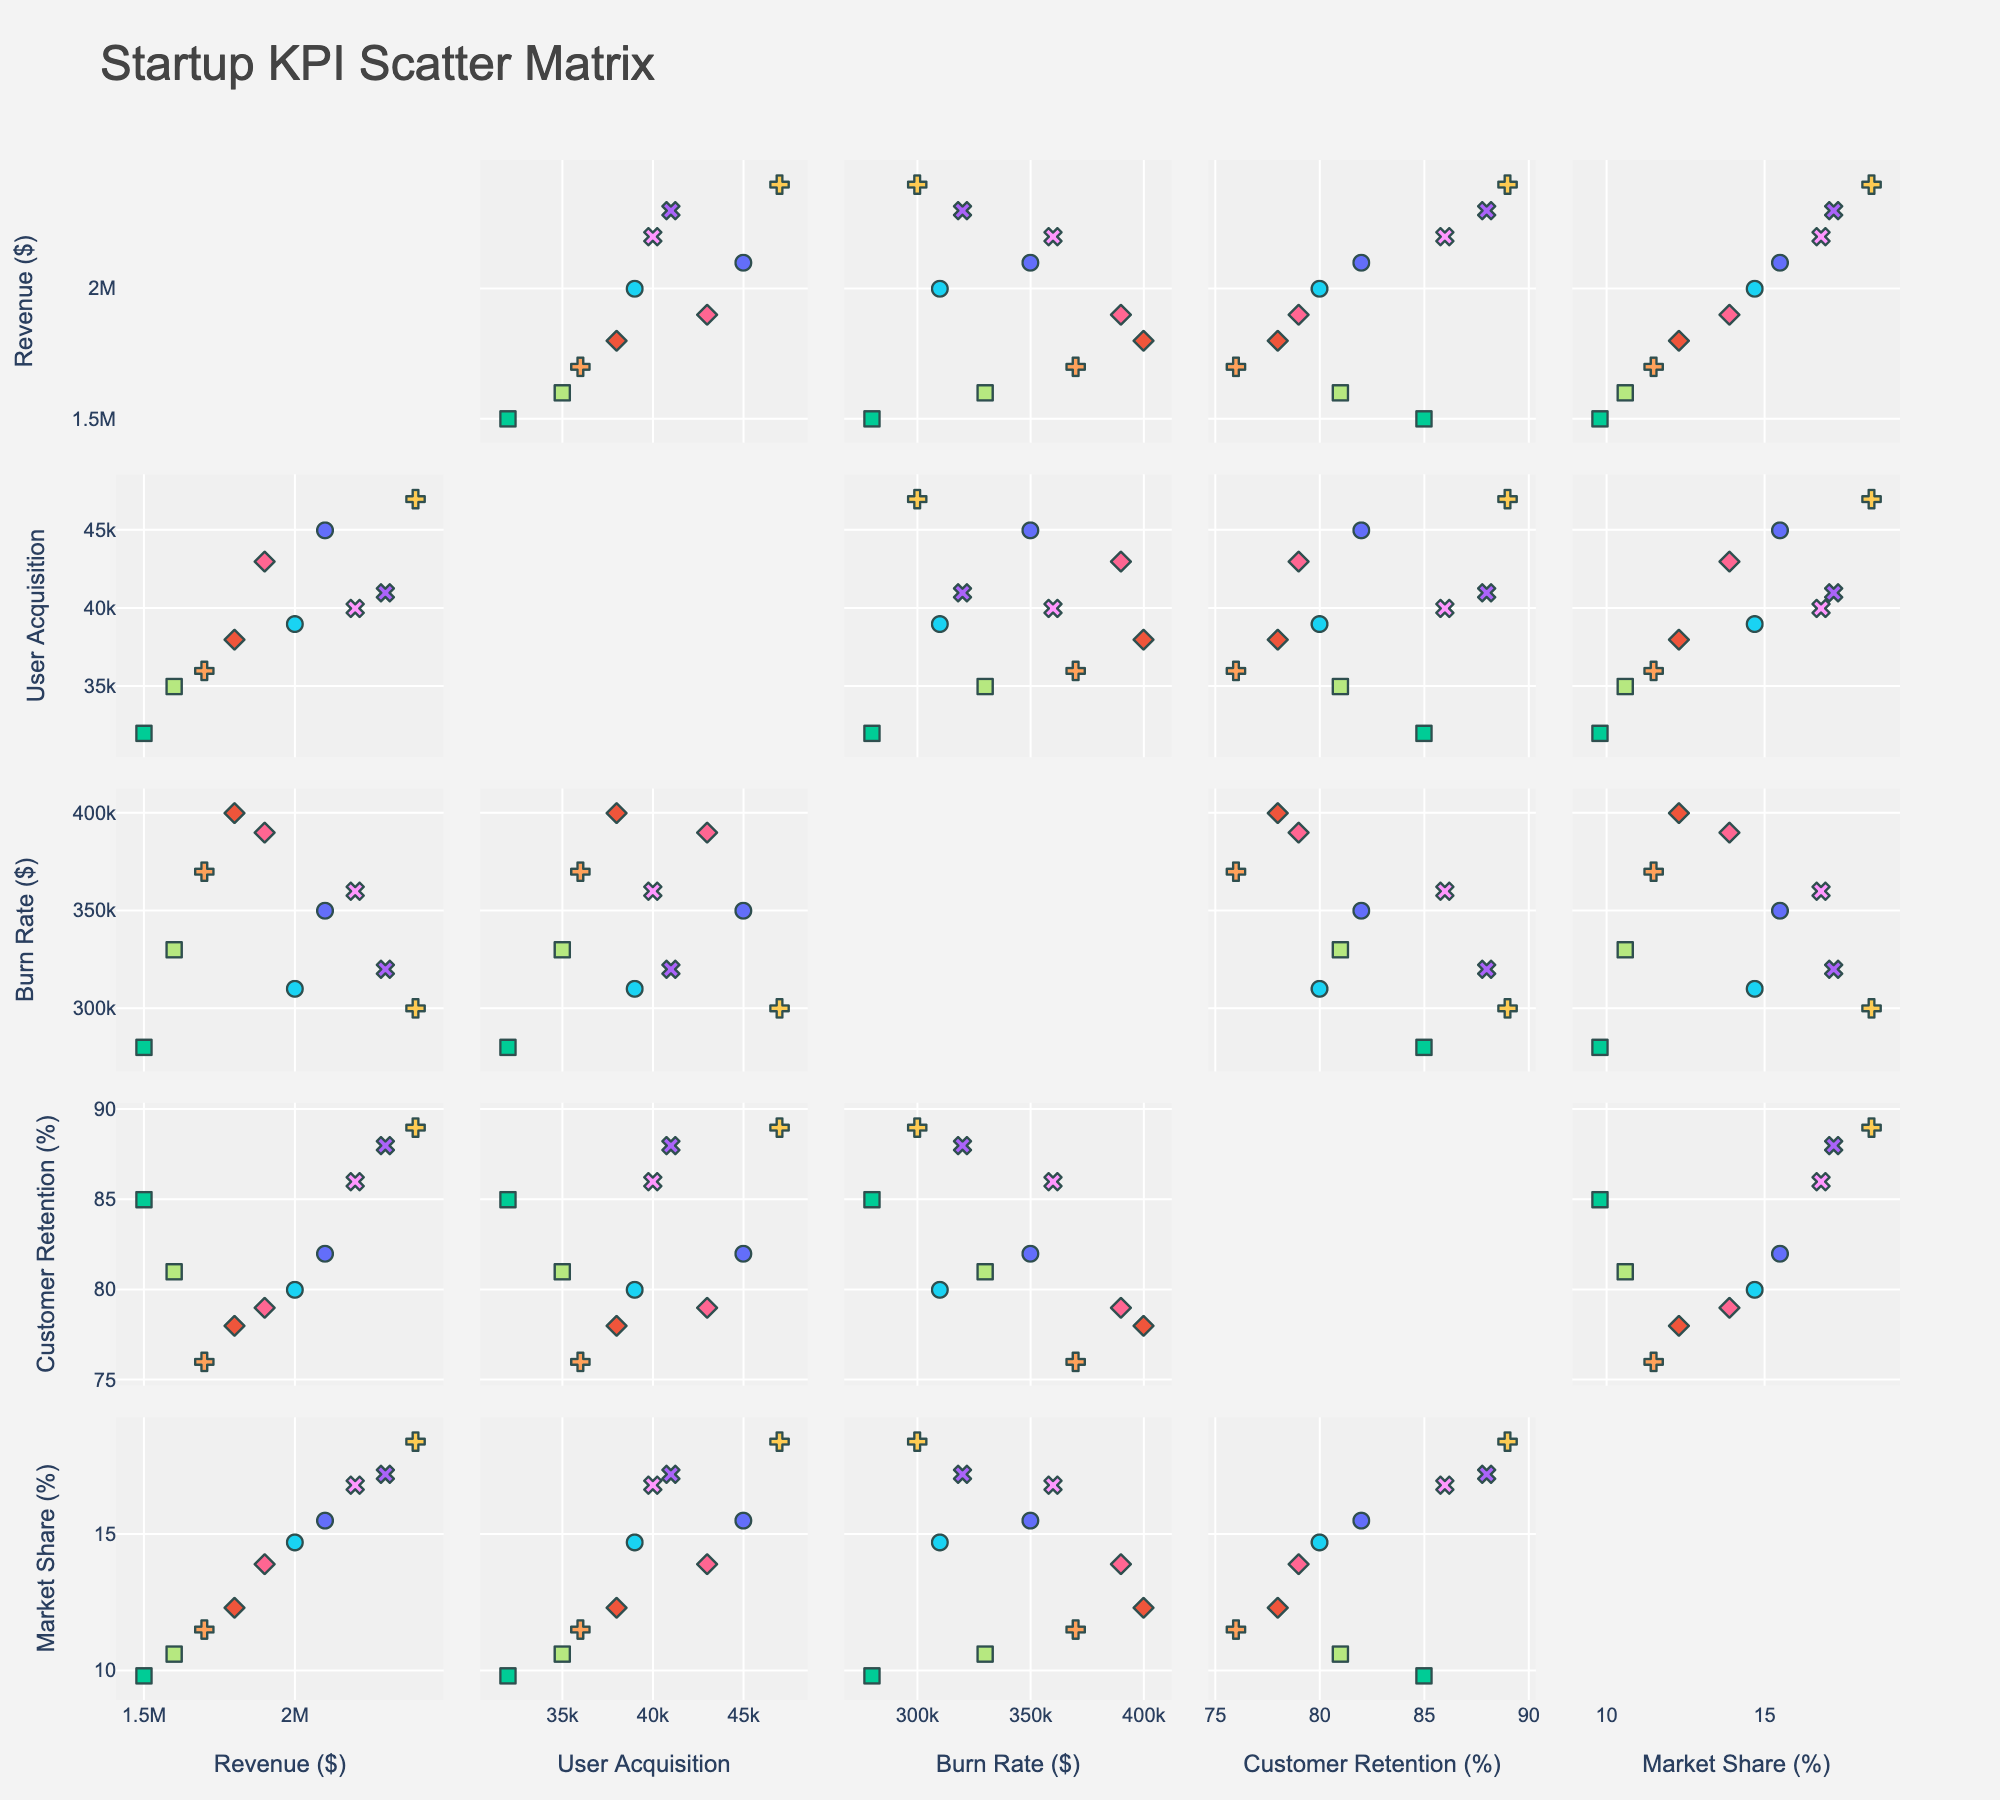What is the title of the figure? To determine the title, look at the top of the figure where the title is usually located.
Answer: Startup KPI Scatter Matrix How many companies are represented in the scatterplot matrix? Count the unique markers or labels corresponding to different companies in the legend or plot.
Answer: 10 Which company has the highest revenue? Locate the "Revenue" dimension, look for the highest data point in that column.
Answer: Zoom What is the relationship between Revenue and User Acquisition for the company Zoom? Find the Zoom markers and check the positions on the "Revenue" and "User Acquisition" axes.
Answer: High Revenue, High User Acquisition Which company shows the lowest burn rate? Locate the "Burn Rate" dimension and identify the lowest value or data point.
Answer: Slack Compare the Burn Rate and Customer Retention of Slack and Uber. Who has a better retention rate? Check Slack and Uber markers for both "Burn Rate" and "Customer Retention" dimensions and compare them.
Answer: Slack Which variable seems positively correlated with Revenue? Analyze "Revenue" and other dimensions horizontally or vertically to identify any upward trends.
Answer: User Acquisition, Market Share Among Palantir and Robinhood, which company has a higher customer retention rate? Locate the markers for Palantir and Robinhood and compare their positions on "Customer Retention" axis.
Answer: Palantir Is there any visible negative correlation between Market Share and Burn Rate? Scan through the scatterplots involving "Market Share" and "Burn Rate" dimensions to look for a downward trend.
Answer: No visible negative correlation What is the relationship between Customer Retention and Market Share for Slack? Identify Slack markers and compare their positions along "Customer Retention" and "Market Share" axes.
Answer: High Retention, Low-Moderate Market Share 